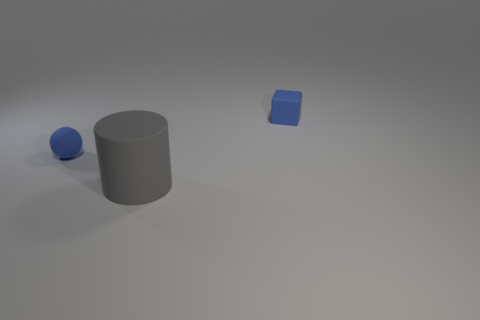Is there anything else that is the same size as the gray rubber cylinder?
Give a very brief answer. No. Does the small blue block have the same material as the tiny blue sphere?
Your answer should be very brief. Yes. How many blue objects are either rubber spheres or tiny matte objects?
Your response must be concise. 2. There is a rubber cylinder; how many things are behind it?
Offer a very short reply. 2. Is the number of red cubes greater than the number of cylinders?
Offer a terse response. No. What shape is the small thing on the left side of the small thing that is to the right of the large gray rubber object?
Ensure brevity in your answer.  Sphere. Does the big thing have the same color as the rubber block?
Provide a short and direct response. No. Is the number of tiny objects on the right side of the blue rubber block greater than the number of large brown rubber objects?
Offer a very short reply. No. There is a blue matte object that is right of the tiny matte ball; how many small blue rubber balls are to the left of it?
Provide a short and direct response. 1. Do the tiny thing in front of the small block and the tiny object to the right of the large gray rubber thing have the same material?
Offer a very short reply. Yes. 